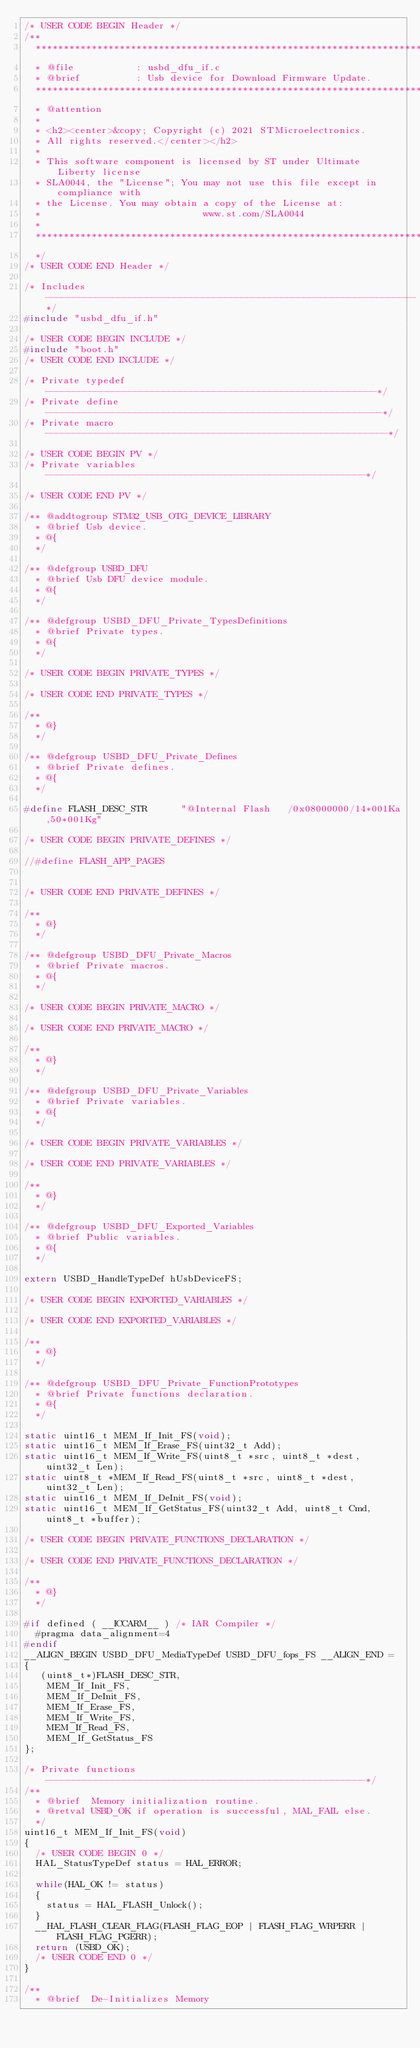<code> <loc_0><loc_0><loc_500><loc_500><_C_>/* USER CODE BEGIN Header */
/**
  ******************************************************************************
  * @file           : usbd_dfu_if.c
  * @brief          : Usb device for Download Firmware Update.
  ******************************************************************************
  * @attention
  *
  * <h2><center>&copy; Copyright (c) 2021 STMicroelectronics.
  * All rights reserved.</center></h2>
  *
  * This software component is licensed by ST under Ultimate Liberty license
  * SLA0044, the "License"; You may not use this file except in compliance with
  * the License. You may obtain a copy of the License at:
  *                             www.st.com/SLA0044
  *
  ******************************************************************************
  */
/* USER CODE END Header */

/* Includes ------------------------------------------------------------------*/
#include "usbd_dfu_if.h"

/* USER CODE BEGIN INCLUDE */
#include "boot.h"
/* USER CODE END INCLUDE */

/* Private typedef -----------------------------------------------------------*/
/* Private define ------------------------------------------------------------*/
/* Private macro -------------------------------------------------------------*/

/* USER CODE BEGIN PV */
/* Private variables ---------------------------------------------------------*/

/* USER CODE END PV */

/** @addtogroup STM32_USB_OTG_DEVICE_LIBRARY
  * @brief Usb device.
  * @{
  */

/** @defgroup USBD_DFU
  * @brief Usb DFU device module.
  * @{
  */

/** @defgroup USBD_DFU_Private_TypesDefinitions
  * @brief Private types.
  * @{
  */

/* USER CODE BEGIN PRIVATE_TYPES */

/* USER CODE END PRIVATE_TYPES */

/**
  * @}
  */

/** @defgroup USBD_DFU_Private_Defines
  * @brief Private defines.
  * @{
  */

#define FLASH_DESC_STR      "@Internal Flash   /0x08000000/14*001Ka,50*001Kg"

/* USER CODE BEGIN PRIVATE_DEFINES */

//#define FLASH_APP_PAGES


/* USER CODE END PRIVATE_DEFINES */

/**
  * @}
  */

/** @defgroup USBD_DFU_Private_Macros
  * @brief Private macros.
  * @{
  */

/* USER CODE BEGIN PRIVATE_MACRO */

/* USER CODE END PRIVATE_MACRO */

/**
  * @}
  */

/** @defgroup USBD_DFU_Private_Variables
  * @brief Private variables.
  * @{
  */

/* USER CODE BEGIN PRIVATE_VARIABLES */

/* USER CODE END PRIVATE_VARIABLES */

/**
  * @}
  */

/** @defgroup USBD_DFU_Exported_Variables
  * @brief Public variables.
  * @{
  */

extern USBD_HandleTypeDef hUsbDeviceFS;

/* USER CODE BEGIN EXPORTED_VARIABLES */

/* USER CODE END EXPORTED_VARIABLES */

/**
  * @}
  */

/** @defgroup USBD_DFU_Private_FunctionPrototypes
  * @brief Private functions declaration.
  * @{
  */

static uint16_t MEM_If_Init_FS(void);
static uint16_t MEM_If_Erase_FS(uint32_t Add);
static uint16_t MEM_If_Write_FS(uint8_t *src, uint8_t *dest, uint32_t Len);
static uint8_t *MEM_If_Read_FS(uint8_t *src, uint8_t *dest, uint32_t Len);
static uint16_t MEM_If_DeInit_FS(void);
static uint16_t MEM_If_GetStatus_FS(uint32_t Add, uint8_t Cmd, uint8_t *buffer);

/* USER CODE BEGIN PRIVATE_FUNCTIONS_DECLARATION */

/* USER CODE END PRIVATE_FUNCTIONS_DECLARATION */

/**
  * @}
  */

#if defined ( __ICCARM__ ) /* IAR Compiler */
  #pragma data_alignment=4
#endif
__ALIGN_BEGIN USBD_DFU_MediaTypeDef USBD_DFU_fops_FS __ALIGN_END =
{
   (uint8_t*)FLASH_DESC_STR,
    MEM_If_Init_FS,
    MEM_If_DeInit_FS,
    MEM_If_Erase_FS,
    MEM_If_Write_FS,
    MEM_If_Read_FS,
    MEM_If_GetStatus_FS
};

/* Private functions ---------------------------------------------------------*/
/**
  * @brief  Memory initialization routine.
  * @retval USBD_OK if operation is successful, MAL_FAIL else.
  */
uint16_t MEM_If_Init_FS(void)
{
  /* USER CODE BEGIN 0 */
	HAL_StatusTypeDef status = HAL_ERROR;
	
  while(HAL_OK != status)
  {
    status = HAL_FLASH_Unlock();
  }	
  __HAL_FLASH_CLEAR_FLAG(FLASH_FLAG_EOP | FLASH_FLAG_WRPERR | FLASH_FLAG_PGERR);
  return (USBD_OK);
  /* USER CODE END 0 */
}

/**
  * @brief  De-Initializes Memory</code> 